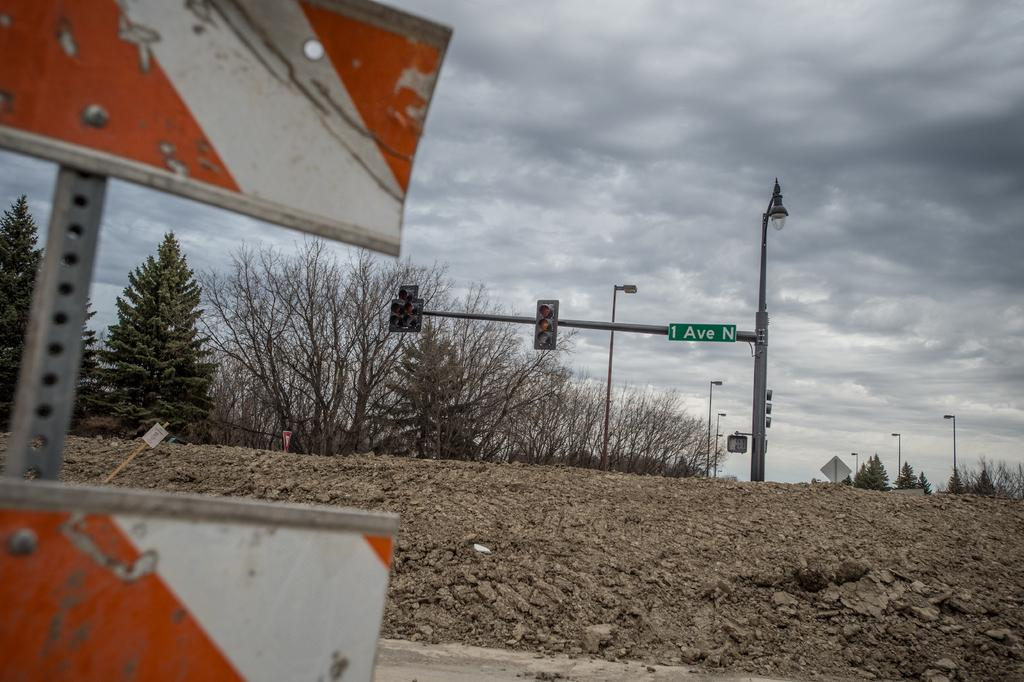<image>
Offer a succinct explanation of the picture presented. An orange barricade within view of 1 Ave N. 